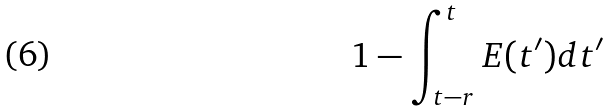Convert formula to latex. <formula><loc_0><loc_0><loc_500><loc_500>1 - \int _ { t - r } ^ { t } E ( t ^ { \prime } ) d t ^ { \prime }</formula> 